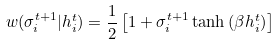<formula> <loc_0><loc_0><loc_500><loc_500>w ( \sigma _ { i } ^ { t + 1 } | h _ { i } ^ { t } ) = \frac { 1 } { 2 } \left [ 1 + \sigma _ { i } ^ { t + 1 } \tanh { ( \beta h _ { i } ^ { t } ) } \right ] \,</formula> 